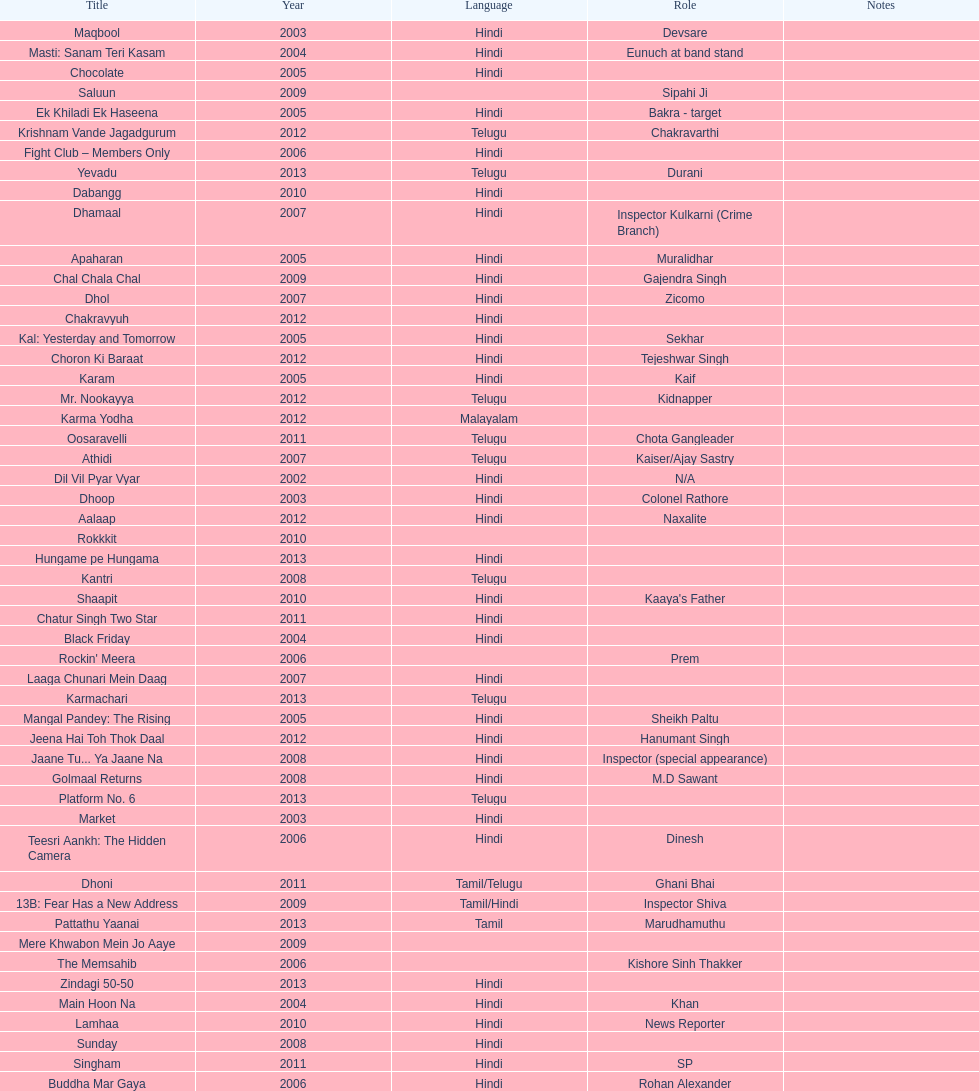Does maqbool have longer notes than shakti? No. 